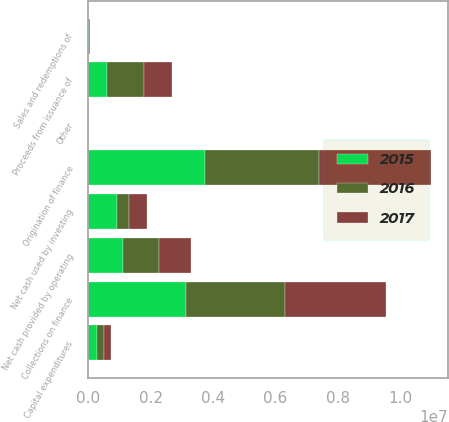Convert chart. <chart><loc_0><loc_0><loc_500><loc_500><stacked_bar_chart><ecel><fcel>Net cash provided by operating<fcel>Capital expenditures<fcel>Origination of finance<fcel>Collections on finance<fcel>Sales and redemptions of<fcel>Other<fcel>Net cash used by investing<fcel>Proceeds from issuance of<nl><fcel>2017<fcel>1.00506e+06<fcel>206294<fcel>3.59195e+06<fcel>3.22831e+06<fcel>6916<fcel>547<fcel>562468<fcel>893668<nl><fcel>2016<fcel>1.17434e+06<fcel>256263<fcel>3.6645e+06<fcel>3.17503e+06<fcel>40014<fcel>411<fcel>392731<fcel>1.1934e+06<nl><fcel>2015<fcel>1.10012e+06<fcel>259974<fcel>3.75183e+06<fcel>3.13688e+06<fcel>11507<fcel>7474<fcel>915848<fcel>595386<nl></chart> 